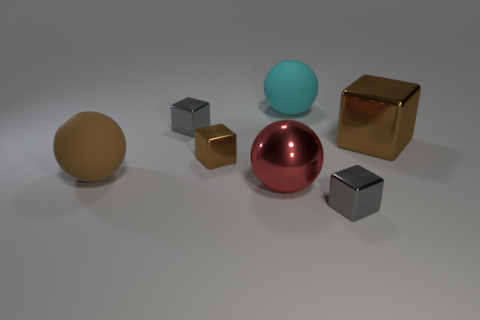There is a gray cube that is in front of the large matte ball in front of the small brown shiny object; how many brown rubber objects are behind it? While we cannot determine the material of the objects from the image alone, based on the provided description, there appears to be one small brown object that could be construed as being made of rubber. Therefore, there's one brown object that might be described as a rubber object behind the gray cube. 